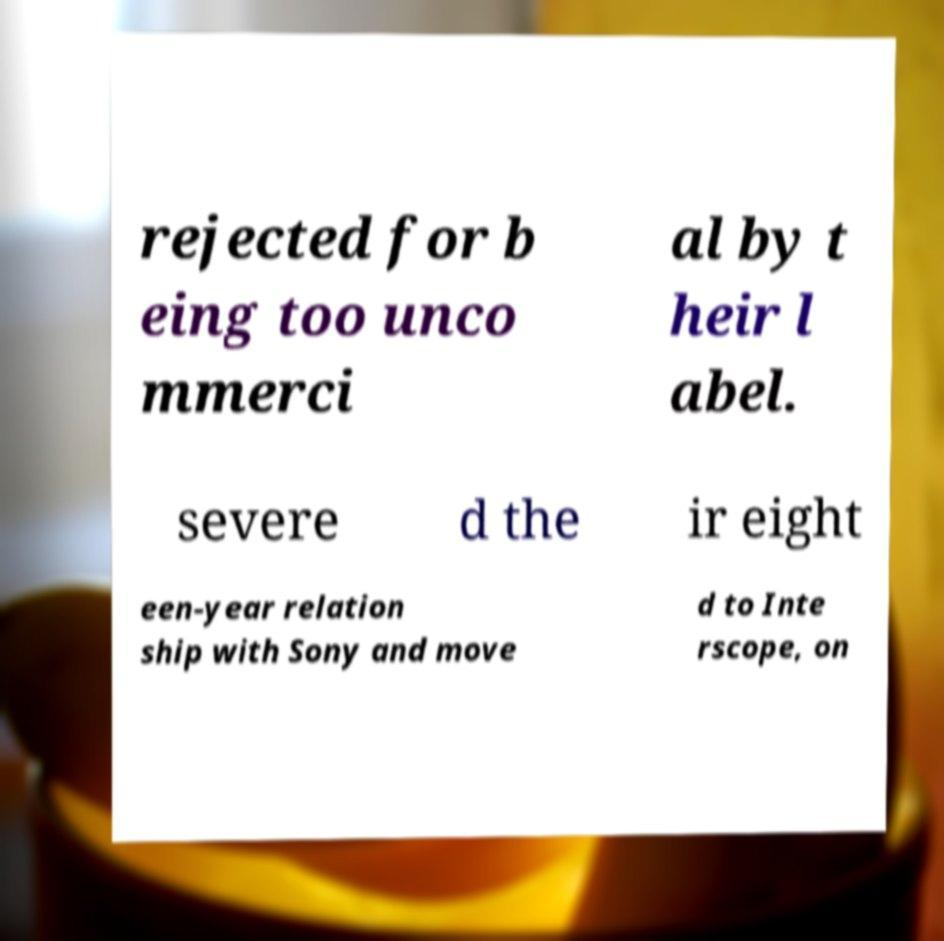Please identify and transcribe the text found in this image. rejected for b eing too unco mmerci al by t heir l abel. severe d the ir eight een-year relation ship with Sony and move d to Inte rscope, on 